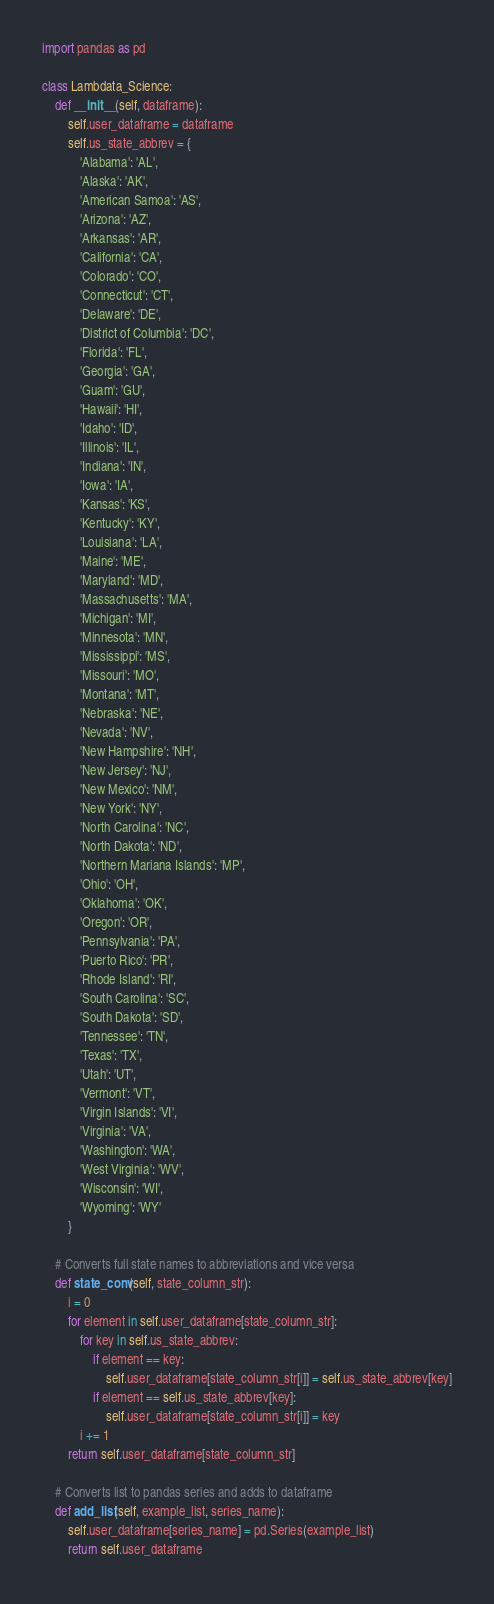Convert code to text. <code><loc_0><loc_0><loc_500><loc_500><_Python_>import pandas as pd

class Lambdata_Science:
    def __init__(self, dataframe):
        self.user_dataframe = dataframe
        self.us_state_abbrev = {
            'Alabama': 'AL',
            'Alaska': 'AK',
            'American Samoa': 'AS',
            'Arizona': 'AZ',
            'Arkansas': 'AR',
            'California': 'CA',
            'Colorado': 'CO',
            'Connecticut': 'CT',
            'Delaware': 'DE',
            'District of Columbia': 'DC',
            'Florida': 'FL',
            'Georgia': 'GA',
            'Guam': 'GU',
            'Hawaii': 'HI',
            'Idaho': 'ID',
            'Illinois': 'IL',
            'Indiana': 'IN',
            'Iowa': 'IA',
            'Kansas': 'KS',
            'Kentucky': 'KY',
            'Louisiana': 'LA',
            'Maine': 'ME',
            'Maryland': 'MD',
            'Massachusetts': 'MA',
            'Michigan': 'MI',
            'Minnesota': 'MN',
            'Mississippi': 'MS',
            'Missouri': 'MO',
            'Montana': 'MT',
            'Nebraska': 'NE',
            'Nevada': 'NV',
            'New Hampshire': 'NH',
            'New Jersey': 'NJ',
            'New Mexico': 'NM',
            'New York': 'NY',
            'North Carolina': 'NC',
            'North Dakota': 'ND',
            'Northern Mariana Islands': 'MP',
            'Ohio': 'OH',
            'Oklahoma': 'OK',
            'Oregon': 'OR',
            'Pennsylvania': 'PA',
            'Puerto Rico': 'PR',
            'Rhode Island': 'RI',
            'South Carolina': 'SC',
            'South Dakota': 'SD',
            'Tennessee': 'TN',
            'Texas': 'TX',
            'Utah': 'UT',
            'Vermont': 'VT',
            'Virgin Islands': 'VI',
            'Virginia': 'VA',
            'Washington': 'WA',
            'West Virginia': 'WV',
            'Wisconsin': 'WI',
            'Wyoming': 'WY'
        }

    # Converts full state names to abbreviations and vice versa
    def state_conv(self, state_column_str):  
        i = 0
        for element in self.user_dataframe[state_column_str]:
            for key in self.us_state_abbrev:
                if element == key:
                    self.user_dataframe[state_column_str[i]] = self.us_state_abbrev[key]
                if element == self.us_state_abbrev[key]:
                    self.user_dataframe[state_column_str[i]] = key
            i += 1
        return self.user_dataframe[state_column_str]

    # Converts list to pandas series and adds to dataframe
    def add_list(self, example_list, series_name):
        self.user_dataframe[series_name] = pd.Series(example_list)
        return self.user_dataframe</code> 